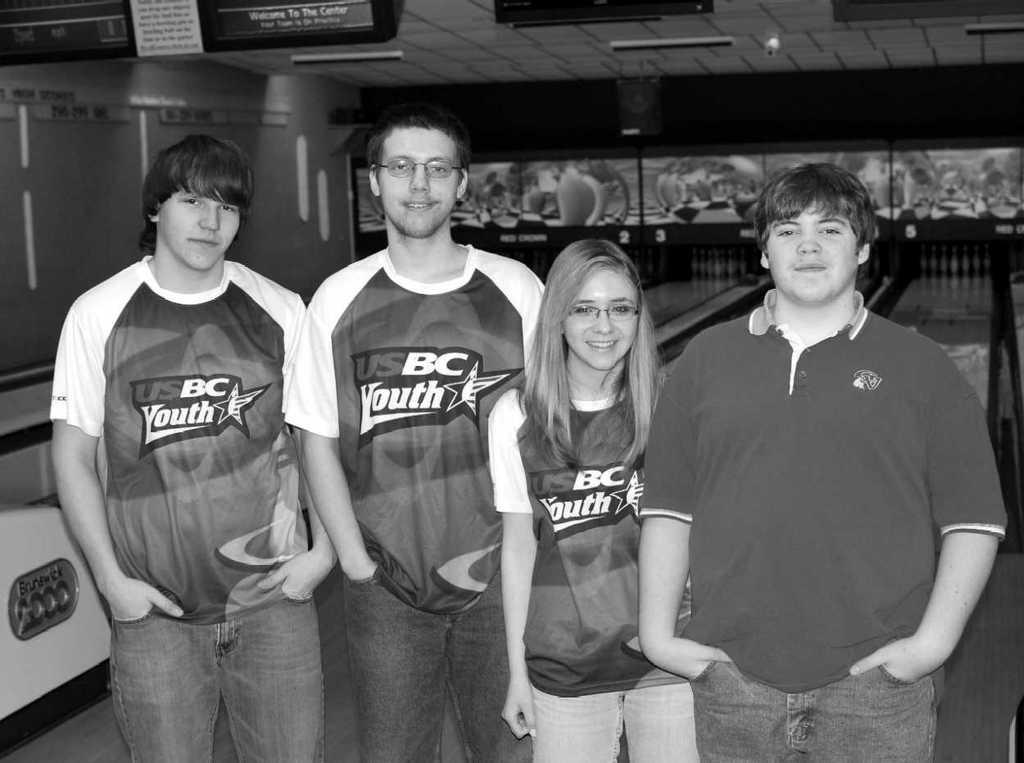Who or what can be seen in the foreground of the image? There are people in the foreground of the image. What structure is visible in the image? There is a roof visible in the image. What is on the roof? There are lights on the roof. What activity might be taking place in the image? A play board is visible in the image, suggesting a game or activity is happening. What time of day is it in the image, and who is the father of the cent? The time of day cannot be determined from the image, and there is no cent or father mentioned in the image. 